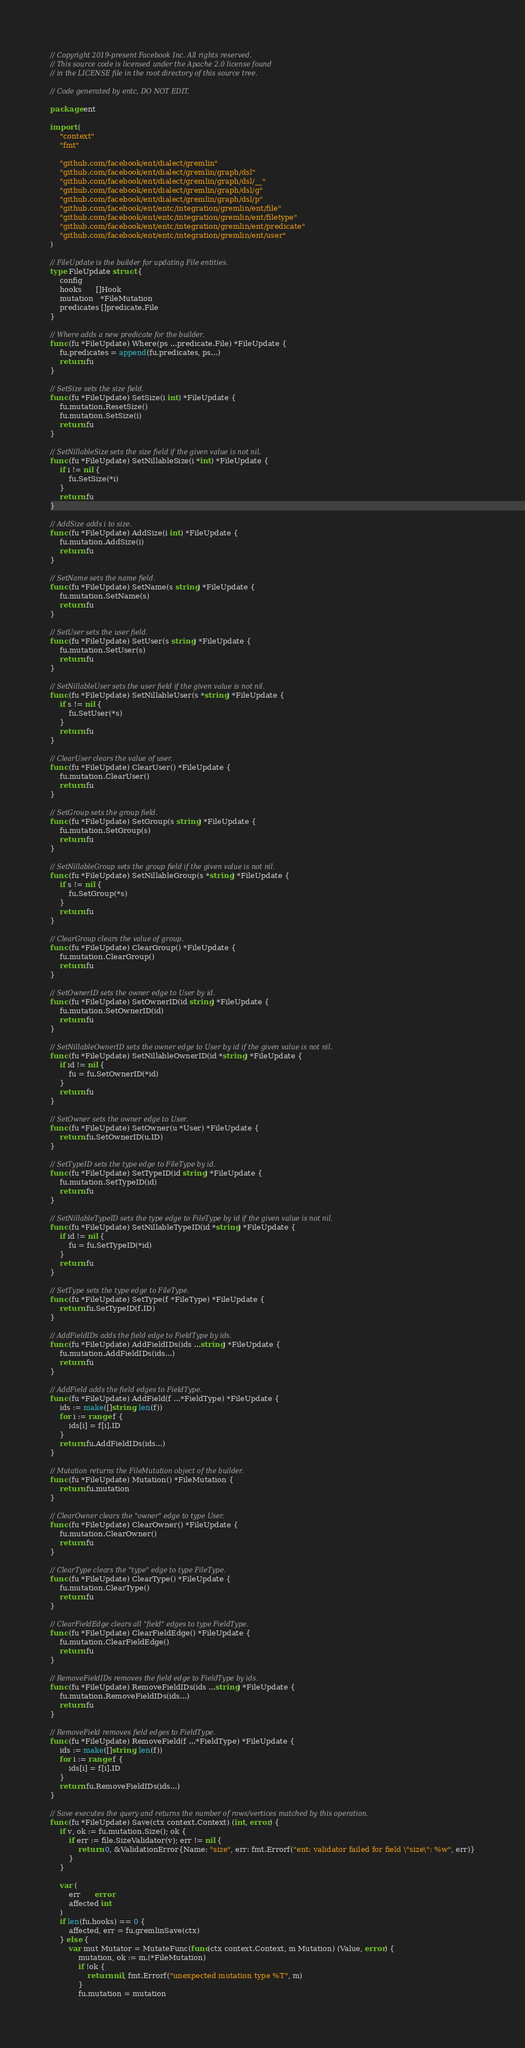Convert code to text. <code><loc_0><loc_0><loc_500><loc_500><_Go_>// Copyright 2019-present Facebook Inc. All rights reserved.
// This source code is licensed under the Apache 2.0 license found
// in the LICENSE file in the root directory of this source tree.

// Code generated by entc, DO NOT EDIT.

package ent

import (
	"context"
	"fmt"

	"github.com/facebook/ent/dialect/gremlin"
	"github.com/facebook/ent/dialect/gremlin/graph/dsl"
	"github.com/facebook/ent/dialect/gremlin/graph/dsl/__"
	"github.com/facebook/ent/dialect/gremlin/graph/dsl/g"
	"github.com/facebook/ent/dialect/gremlin/graph/dsl/p"
	"github.com/facebook/ent/entc/integration/gremlin/ent/file"
	"github.com/facebook/ent/entc/integration/gremlin/ent/filetype"
	"github.com/facebook/ent/entc/integration/gremlin/ent/predicate"
	"github.com/facebook/ent/entc/integration/gremlin/ent/user"
)

// FileUpdate is the builder for updating File entities.
type FileUpdate struct {
	config
	hooks      []Hook
	mutation   *FileMutation
	predicates []predicate.File
}

// Where adds a new predicate for the builder.
func (fu *FileUpdate) Where(ps ...predicate.File) *FileUpdate {
	fu.predicates = append(fu.predicates, ps...)
	return fu
}

// SetSize sets the size field.
func (fu *FileUpdate) SetSize(i int) *FileUpdate {
	fu.mutation.ResetSize()
	fu.mutation.SetSize(i)
	return fu
}

// SetNillableSize sets the size field if the given value is not nil.
func (fu *FileUpdate) SetNillableSize(i *int) *FileUpdate {
	if i != nil {
		fu.SetSize(*i)
	}
	return fu
}

// AddSize adds i to size.
func (fu *FileUpdate) AddSize(i int) *FileUpdate {
	fu.mutation.AddSize(i)
	return fu
}

// SetName sets the name field.
func (fu *FileUpdate) SetName(s string) *FileUpdate {
	fu.mutation.SetName(s)
	return fu
}

// SetUser sets the user field.
func (fu *FileUpdate) SetUser(s string) *FileUpdate {
	fu.mutation.SetUser(s)
	return fu
}

// SetNillableUser sets the user field if the given value is not nil.
func (fu *FileUpdate) SetNillableUser(s *string) *FileUpdate {
	if s != nil {
		fu.SetUser(*s)
	}
	return fu
}

// ClearUser clears the value of user.
func (fu *FileUpdate) ClearUser() *FileUpdate {
	fu.mutation.ClearUser()
	return fu
}

// SetGroup sets the group field.
func (fu *FileUpdate) SetGroup(s string) *FileUpdate {
	fu.mutation.SetGroup(s)
	return fu
}

// SetNillableGroup sets the group field if the given value is not nil.
func (fu *FileUpdate) SetNillableGroup(s *string) *FileUpdate {
	if s != nil {
		fu.SetGroup(*s)
	}
	return fu
}

// ClearGroup clears the value of group.
func (fu *FileUpdate) ClearGroup() *FileUpdate {
	fu.mutation.ClearGroup()
	return fu
}

// SetOwnerID sets the owner edge to User by id.
func (fu *FileUpdate) SetOwnerID(id string) *FileUpdate {
	fu.mutation.SetOwnerID(id)
	return fu
}

// SetNillableOwnerID sets the owner edge to User by id if the given value is not nil.
func (fu *FileUpdate) SetNillableOwnerID(id *string) *FileUpdate {
	if id != nil {
		fu = fu.SetOwnerID(*id)
	}
	return fu
}

// SetOwner sets the owner edge to User.
func (fu *FileUpdate) SetOwner(u *User) *FileUpdate {
	return fu.SetOwnerID(u.ID)
}

// SetTypeID sets the type edge to FileType by id.
func (fu *FileUpdate) SetTypeID(id string) *FileUpdate {
	fu.mutation.SetTypeID(id)
	return fu
}

// SetNillableTypeID sets the type edge to FileType by id if the given value is not nil.
func (fu *FileUpdate) SetNillableTypeID(id *string) *FileUpdate {
	if id != nil {
		fu = fu.SetTypeID(*id)
	}
	return fu
}

// SetType sets the type edge to FileType.
func (fu *FileUpdate) SetType(f *FileType) *FileUpdate {
	return fu.SetTypeID(f.ID)
}

// AddFieldIDs adds the field edge to FieldType by ids.
func (fu *FileUpdate) AddFieldIDs(ids ...string) *FileUpdate {
	fu.mutation.AddFieldIDs(ids...)
	return fu
}

// AddField adds the field edges to FieldType.
func (fu *FileUpdate) AddField(f ...*FieldType) *FileUpdate {
	ids := make([]string, len(f))
	for i := range f {
		ids[i] = f[i].ID
	}
	return fu.AddFieldIDs(ids...)
}

// Mutation returns the FileMutation object of the builder.
func (fu *FileUpdate) Mutation() *FileMutation {
	return fu.mutation
}

// ClearOwner clears the "owner" edge to type User.
func (fu *FileUpdate) ClearOwner() *FileUpdate {
	fu.mutation.ClearOwner()
	return fu
}

// ClearType clears the "type" edge to type FileType.
func (fu *FileUpdate) ClearType() *FileUpdate {
	fu.mutation.ClearType()
	return fu
}

// ClearFieldEdge clears all "field" edges to type FieldType.
func (fu *FileUpdate) ClearFieldEdge() *FileUpdate {
	fu.mutation.ClearFieldEdge()
	return fu
}

// RemoveFieldIDs removes the field edge to FieldType by ids.
func (fu *FileUpdate) RemoveFieldIDs(ids ...string) *FileUpdate {
	fu.mutation.RemoveFieldIDs(ids...)
	return fu
}

// RemoveField removes field edges to FieldType.
func (fu *FileUpdate) RemoveField(f ...*FieldType) *FileUpdate {
	ids := make([]string, len(f))
	for i := range f {
		ids[i] = f[i].ID
	}
	return fu.RemoveFieldIDs(ids...)
}

// Save executes the query and returns the number of rows/vertices matched by this operation.
func (fu *FileUpdate) Save(ctx context.Context) (int, error) {
	if v, ok := fu.mutation.Size(); ok {
		if err := file.SizeValidator(v); err != nil {
			return 0, &ValidationError{Name: "size", err: fmt.Errorf("ent: validator failed for field \"size\": %w", err)}
		}
	}

	var (
		err      error
		affected int
	)
	if len(fu.hooks) == 0 {
		affected, err = fu.gremlinSave(ctx)
	} else {
		var mut Mutator = MutateFunc(func(ctx context.Context, m Mutation) (Value, error) {
			mutation, ok := m.(*FileMutation)
			if !ok {
				return nil, fmt.Errorf("unexpected mutation type %T", m)
			}
			fu.mutation = mutation</code> 